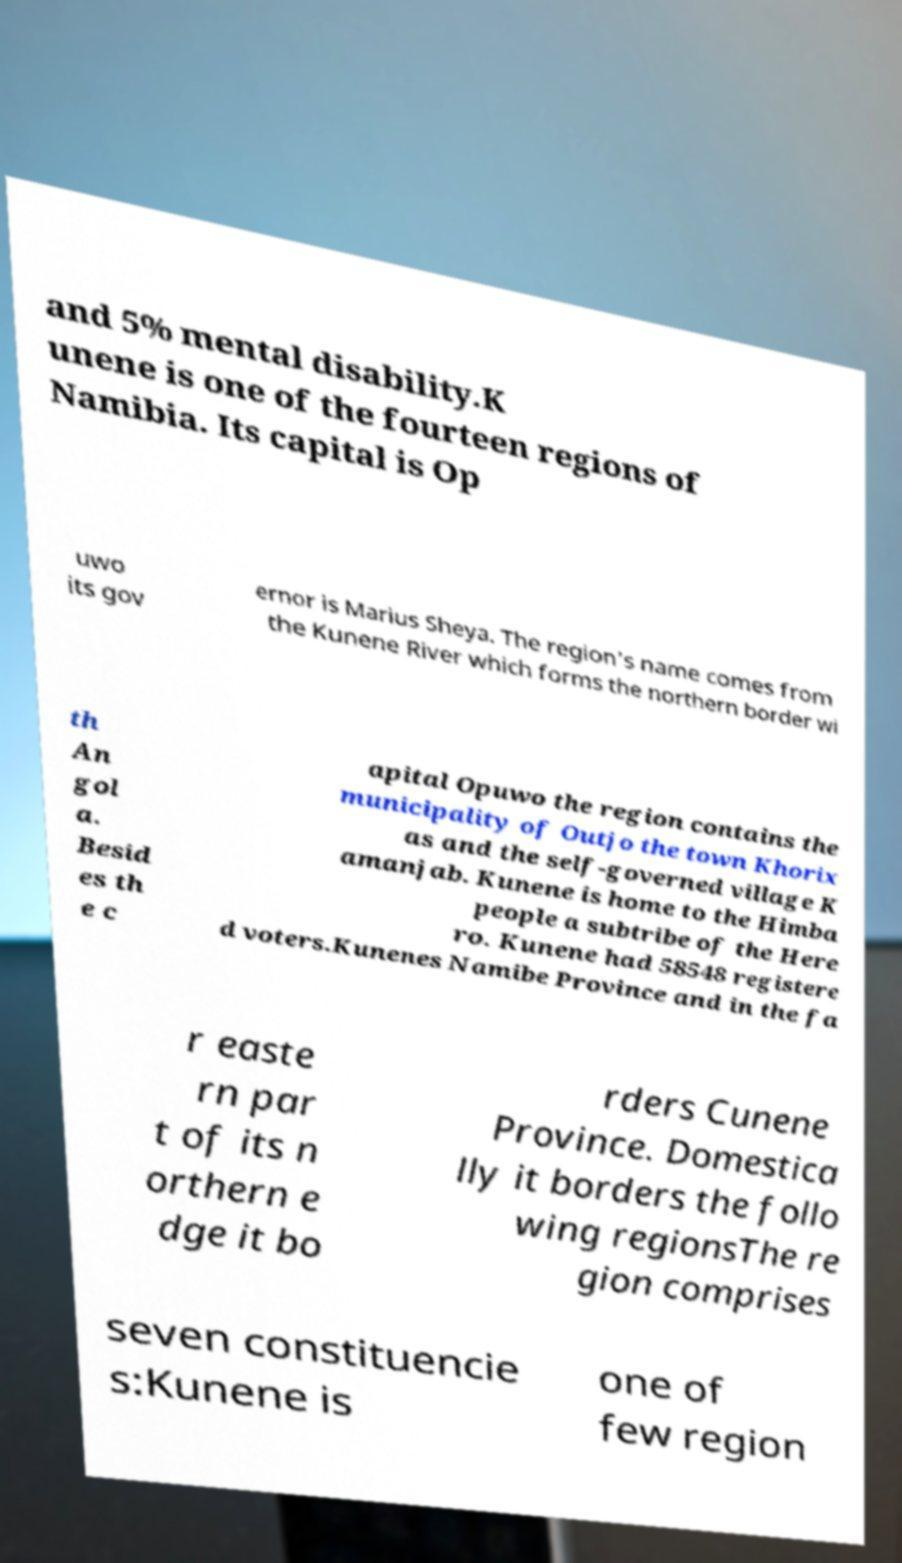What messages or text are displayed in this image? I need them in a readable, typed format. and 5% mental disability.K unene is one of the fourteen regions of Namibia. Its capital is Op uwo its gov ernor is Marius Sheya. The region's name comes from the Kunene River which forms the northern border wi th An gol a. Besid es th e c apital Opuwo the region contains the municipality of Outjo the town Khorix as and the self-governed village K amanjab. Kunene is home to the Himba people a subtribe of the Here ro. Kunene had 58548 registere d voters.Kunenes Namibe Province and in the fa r easte rn par t of its n orthern e dge it bo rders Cunene Province. Domestica lly it borders the follo wing regionsThe re gion comprises seven constituencie s:Kunene is one of few region 